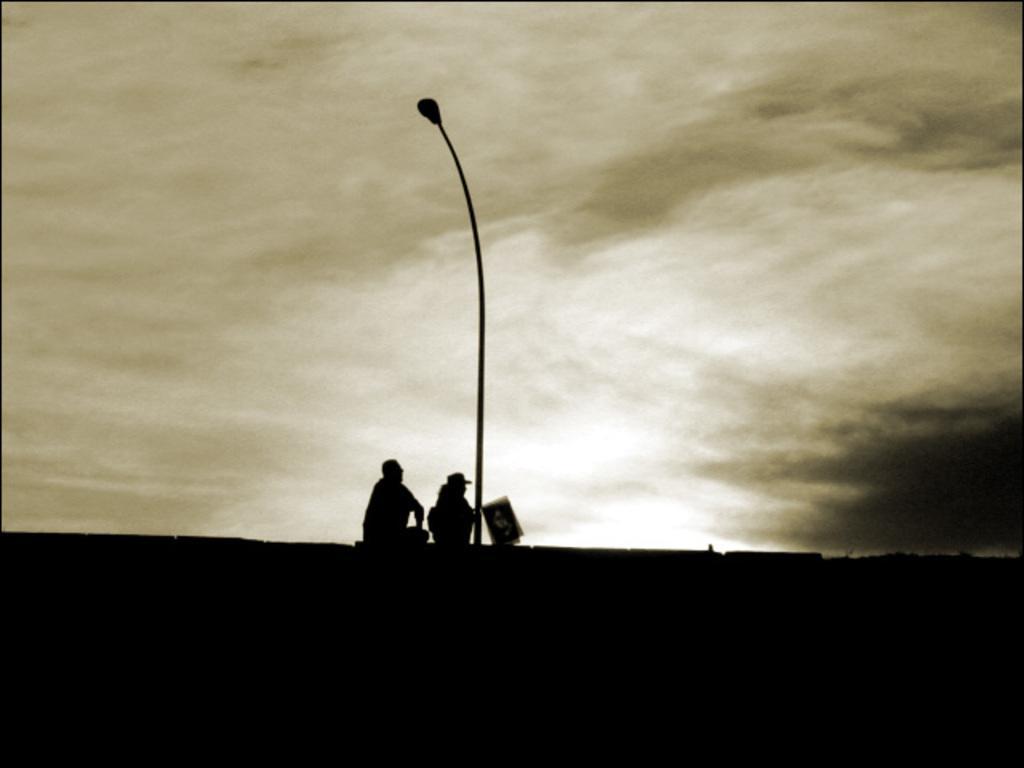Please provide a concise description of this image. In this image we can see two persons sitting at the current pole. In the background there is a sky and clouds. 